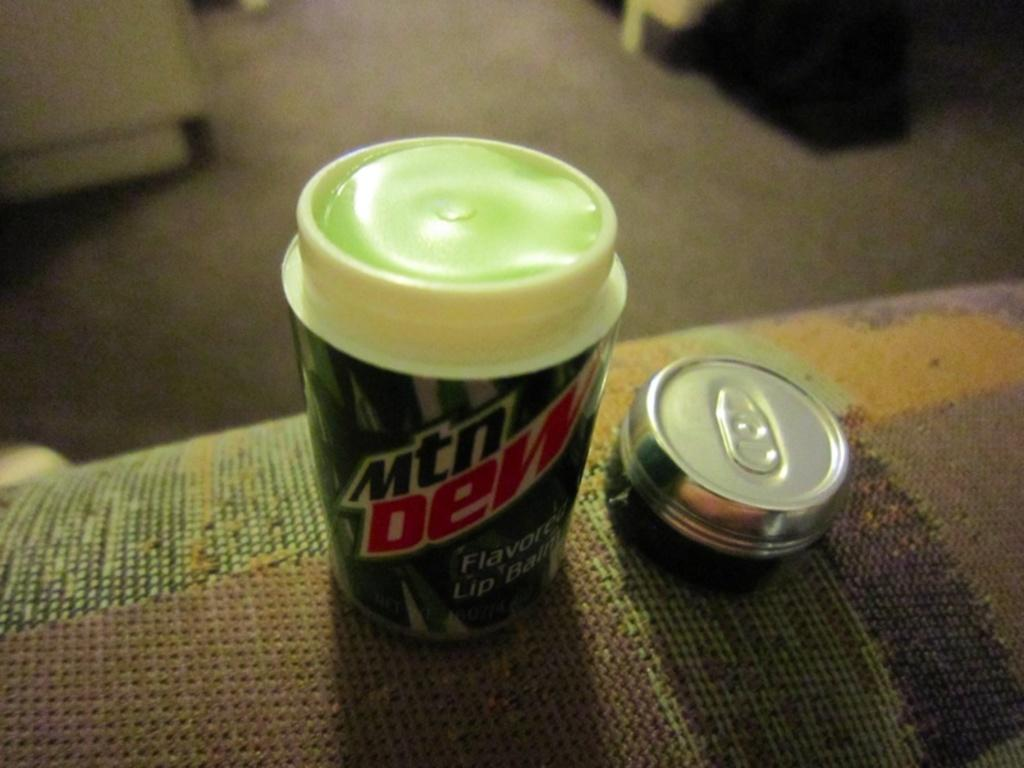<image>
Present a compact description of the photo's key features. The lid of the Mtn Dew lip balm has been taken off. 